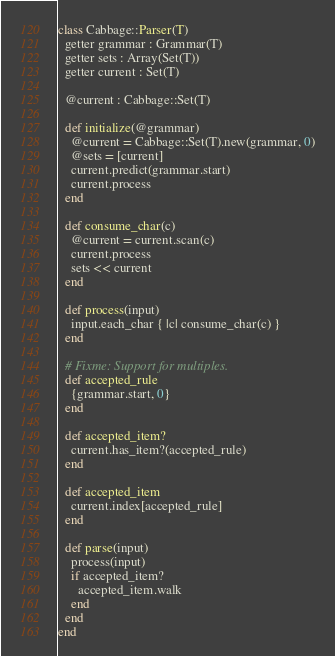<code> <loc_0><loc_0><loc_500><loc_500><_Crystal_>class Cabbage::Parser(T)
  getter grammar : Grammar(T)
  getter sets : Array(Set(T))
  getter current : Set(T)

  @current : Cabbage::Set(T)

  def initialize(@grammar)
    @current = Cabbage::Set(T).new(grammar, 0)
    @sets = [current]
    current.predict(grammar.start)
    current.process
  end

  def consume_char(c)
    @current = current.scan(c)
    current.process
    sets << current
  end

  def process(input)
    input.each_char { |c| consume_char(c) }
  end

  # Fixme: Support for multiples.
  def accepted_rule
    {grammar.start, 0}
  end

  def accepted_item?
    current.has_item?(accepted_rule)
  end

  def accepted_item
    current.index[accepted_rule]
  end

  def parse(input)
    process(input)
    if accepted_item?
      accepted_item.walk
    end
  end
end
</code> 